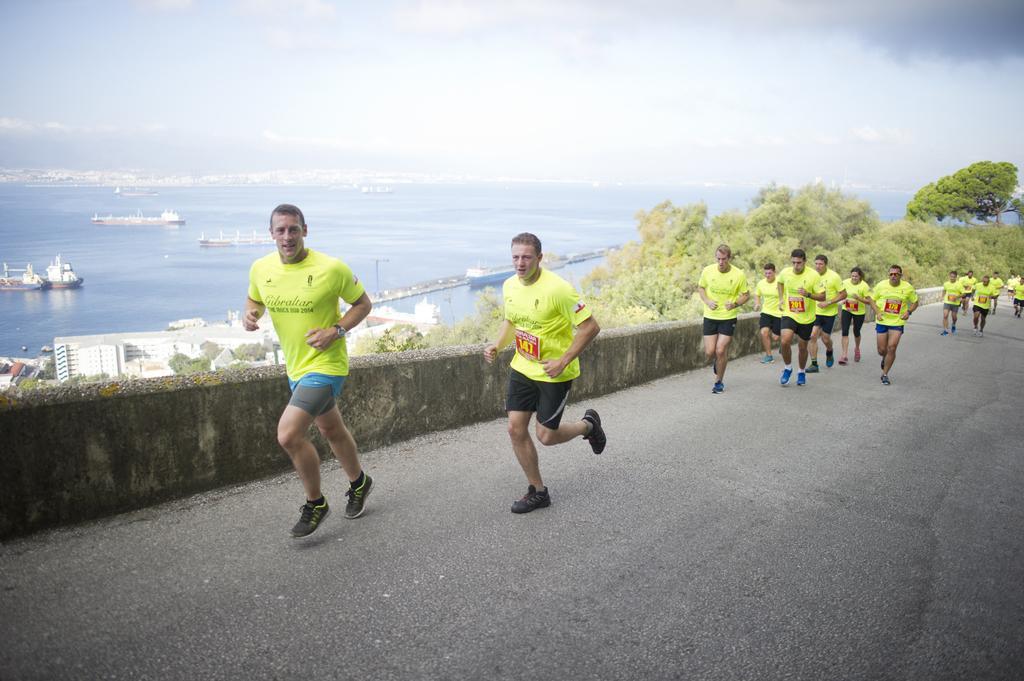In one or two sentences, can you explain what this image depicts? In this image we can see group of men running on the road. In the background we can see buildings, trees, water, ships, sky and clouds. 